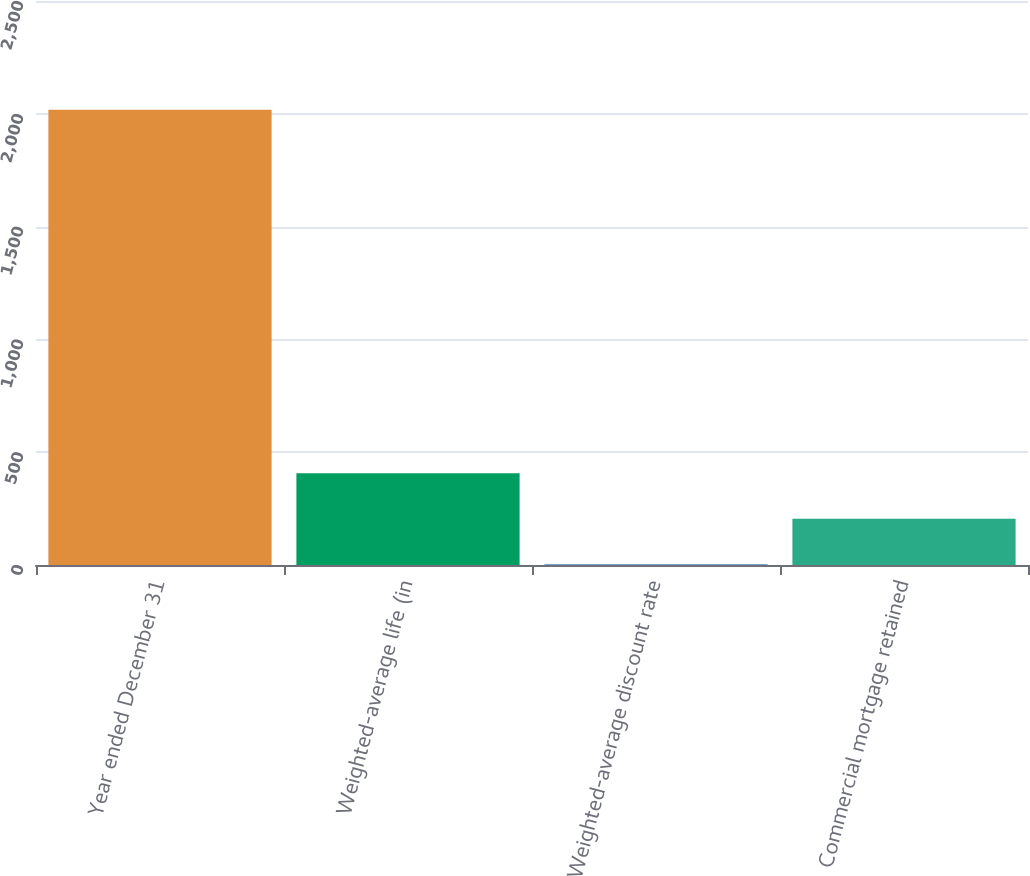<chart> <loc_0><loc_0><loc_500><loc_500><bar_chart><fcel>Year ended December 31<fcel>Weighted-average life (in<fcel>Weighted-average discount rate<fcel>Commercial mortgage retained<nl><fcel>2018<fcel>406.48<fcel>3.6<fcel>205.04<nl></chart> 